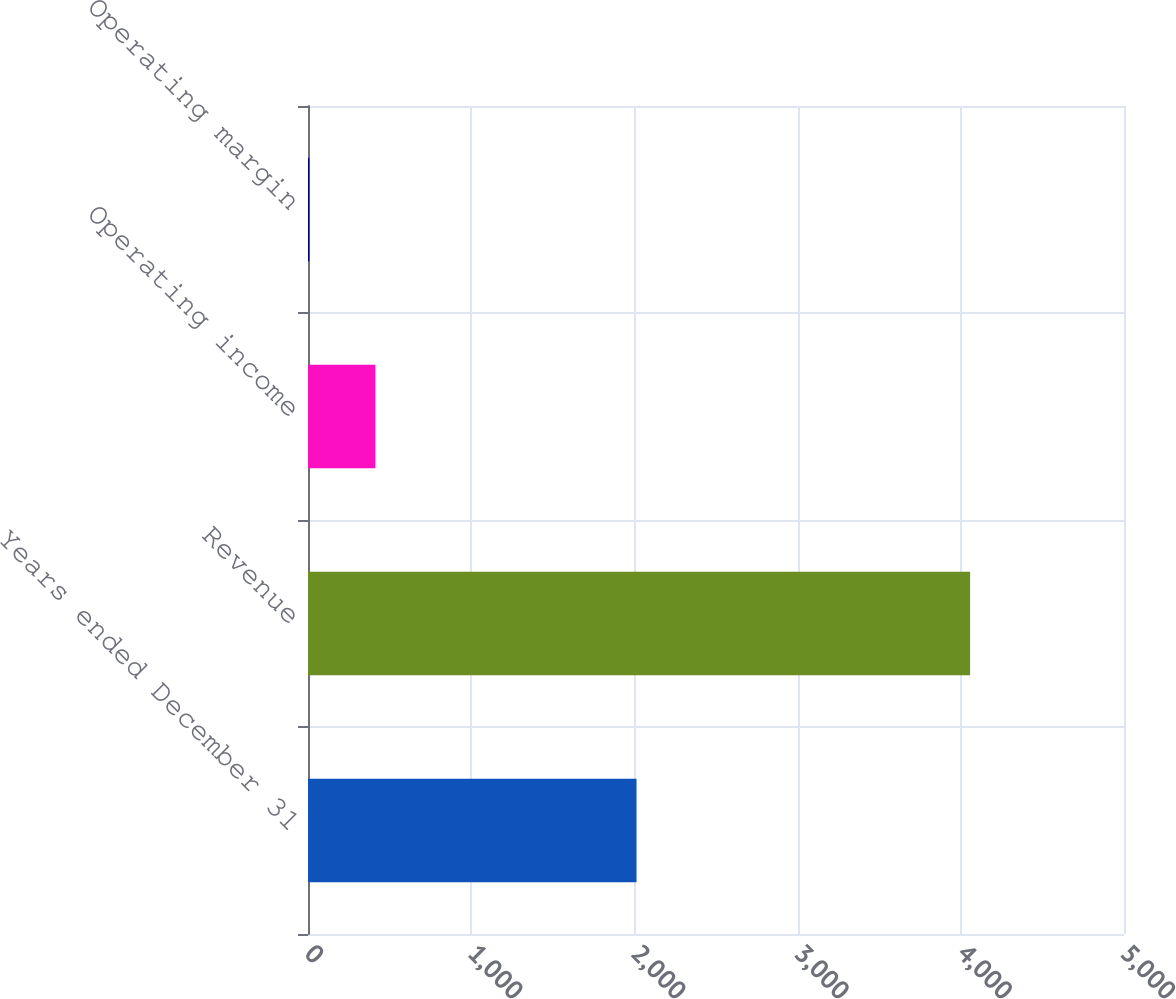<chart> <loc_0><loc_0><loc_500><loc_500><bar_chart><fcel>Years ended December 31<fcel>Revenue<fcel>Operating income<fcel>Operating margin<nl><fcel>2013<fcel>4057<fcel>412.72<fcel>7.8<nl></chart> 